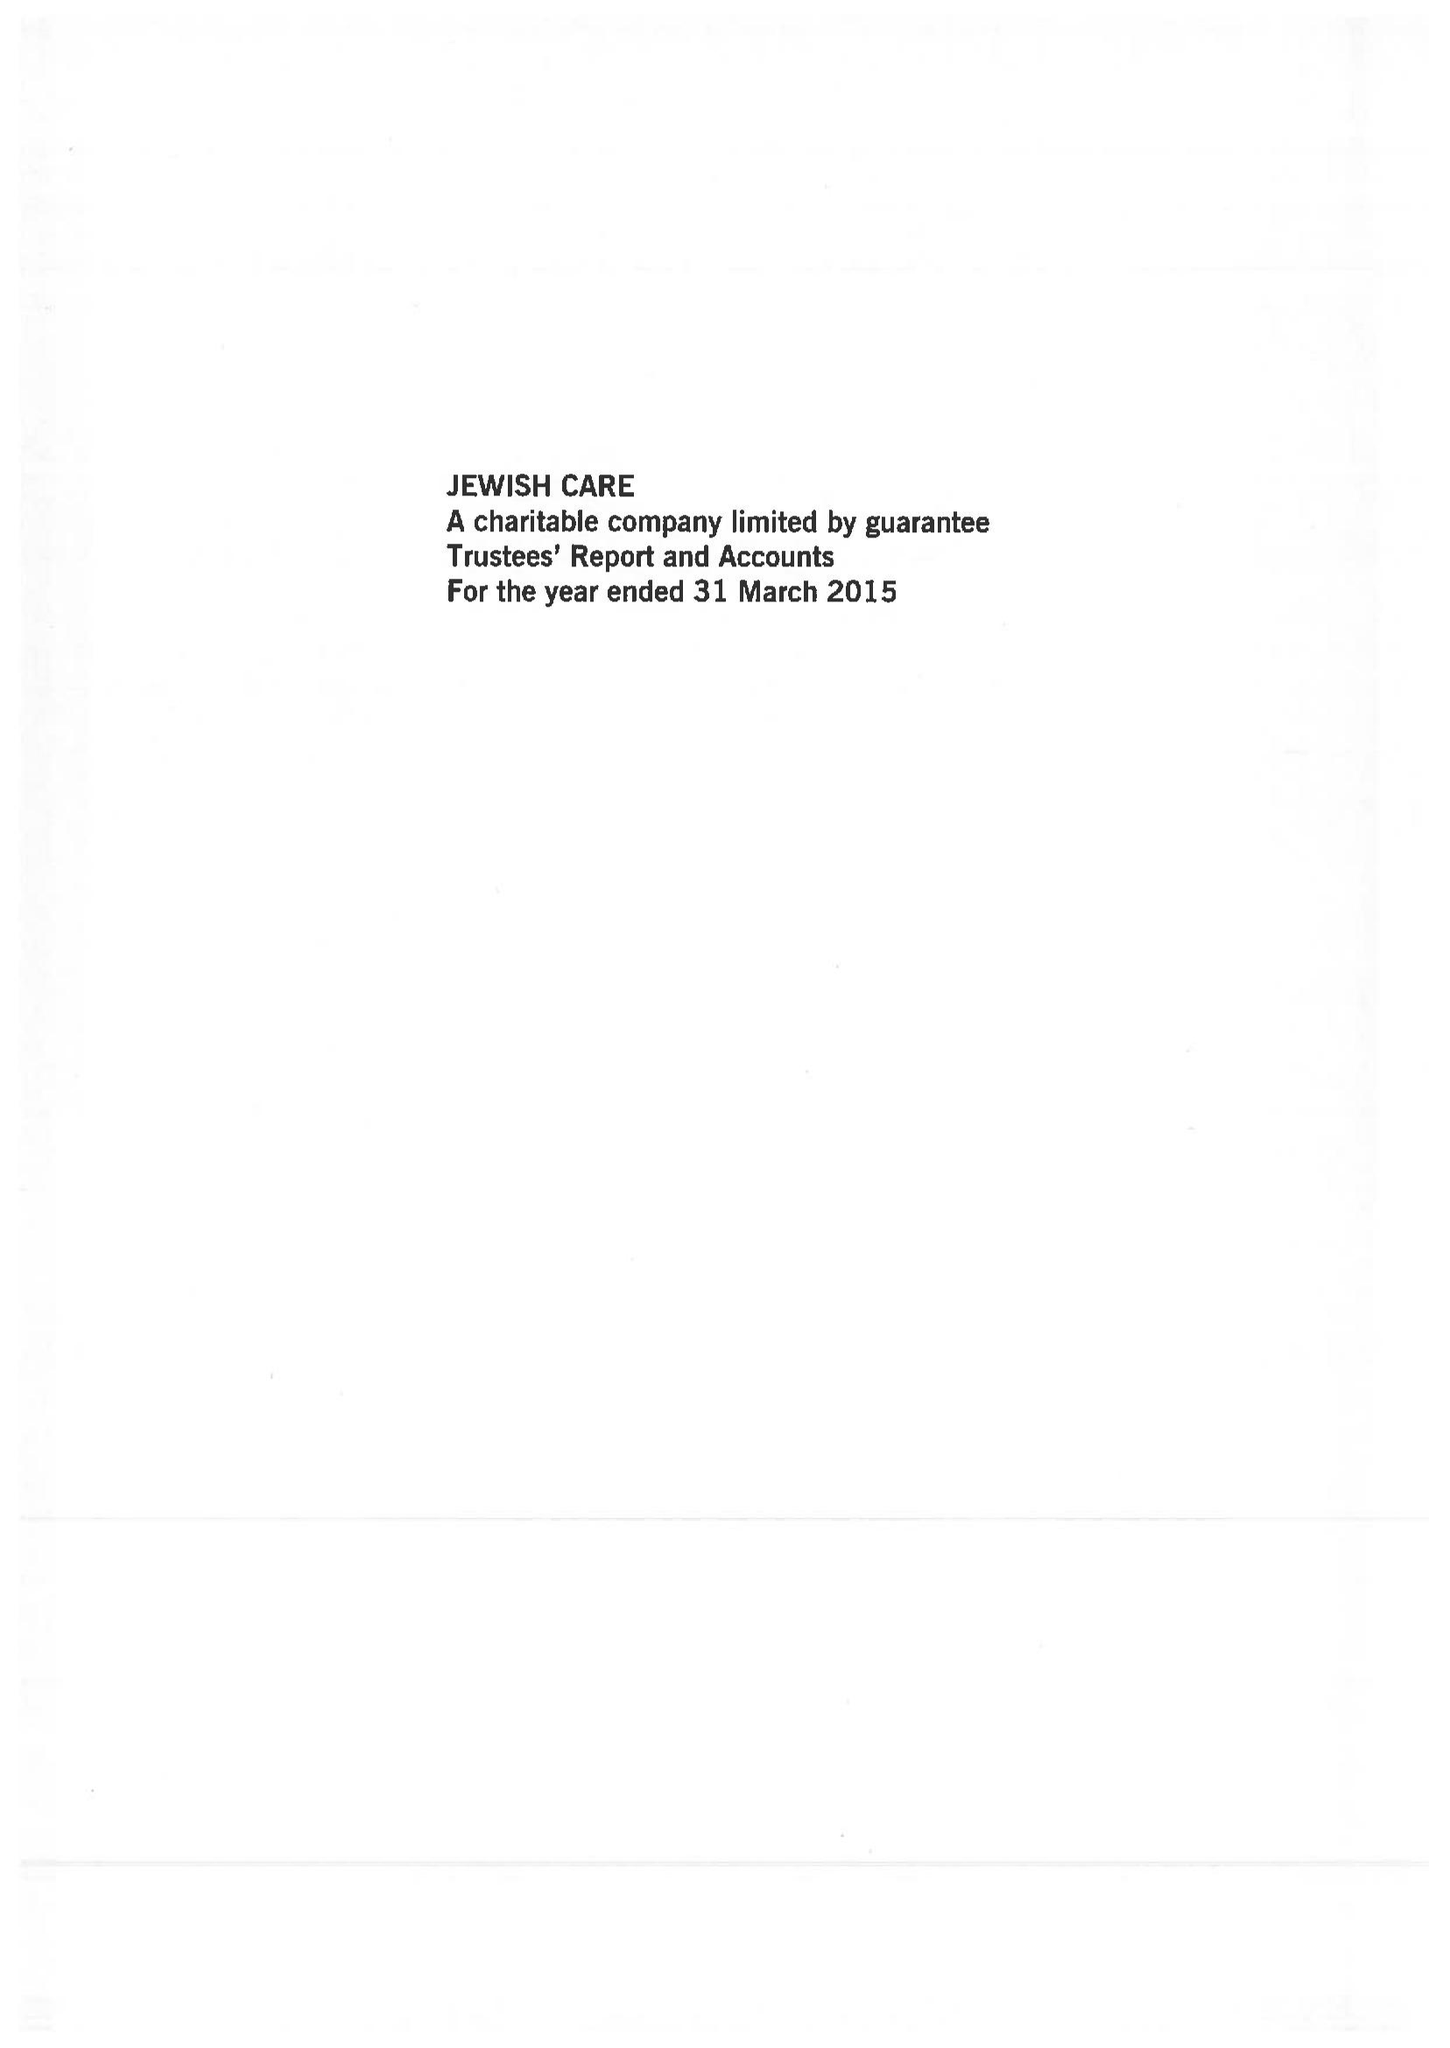What is the value for the address__street_line?
Answer the question using a single word or phrase. 221 GOLDERS GREEN ROAD 